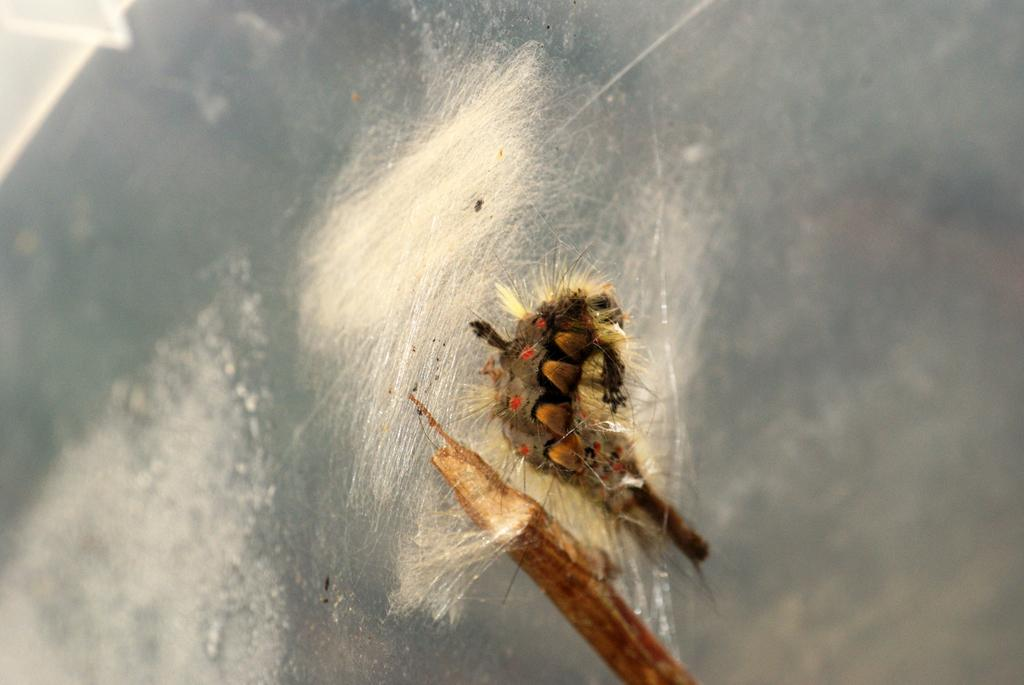How many caterpillars are present in the image? There are two caterpillars in the image. Where are the caterpillars located? The caterpillars are on a surface. What type of statement is being made by the caterpillars in the image? There is no statement being made by the caterpillars in the image, as they are inanimate creatures and cannot communicate in this manner. 